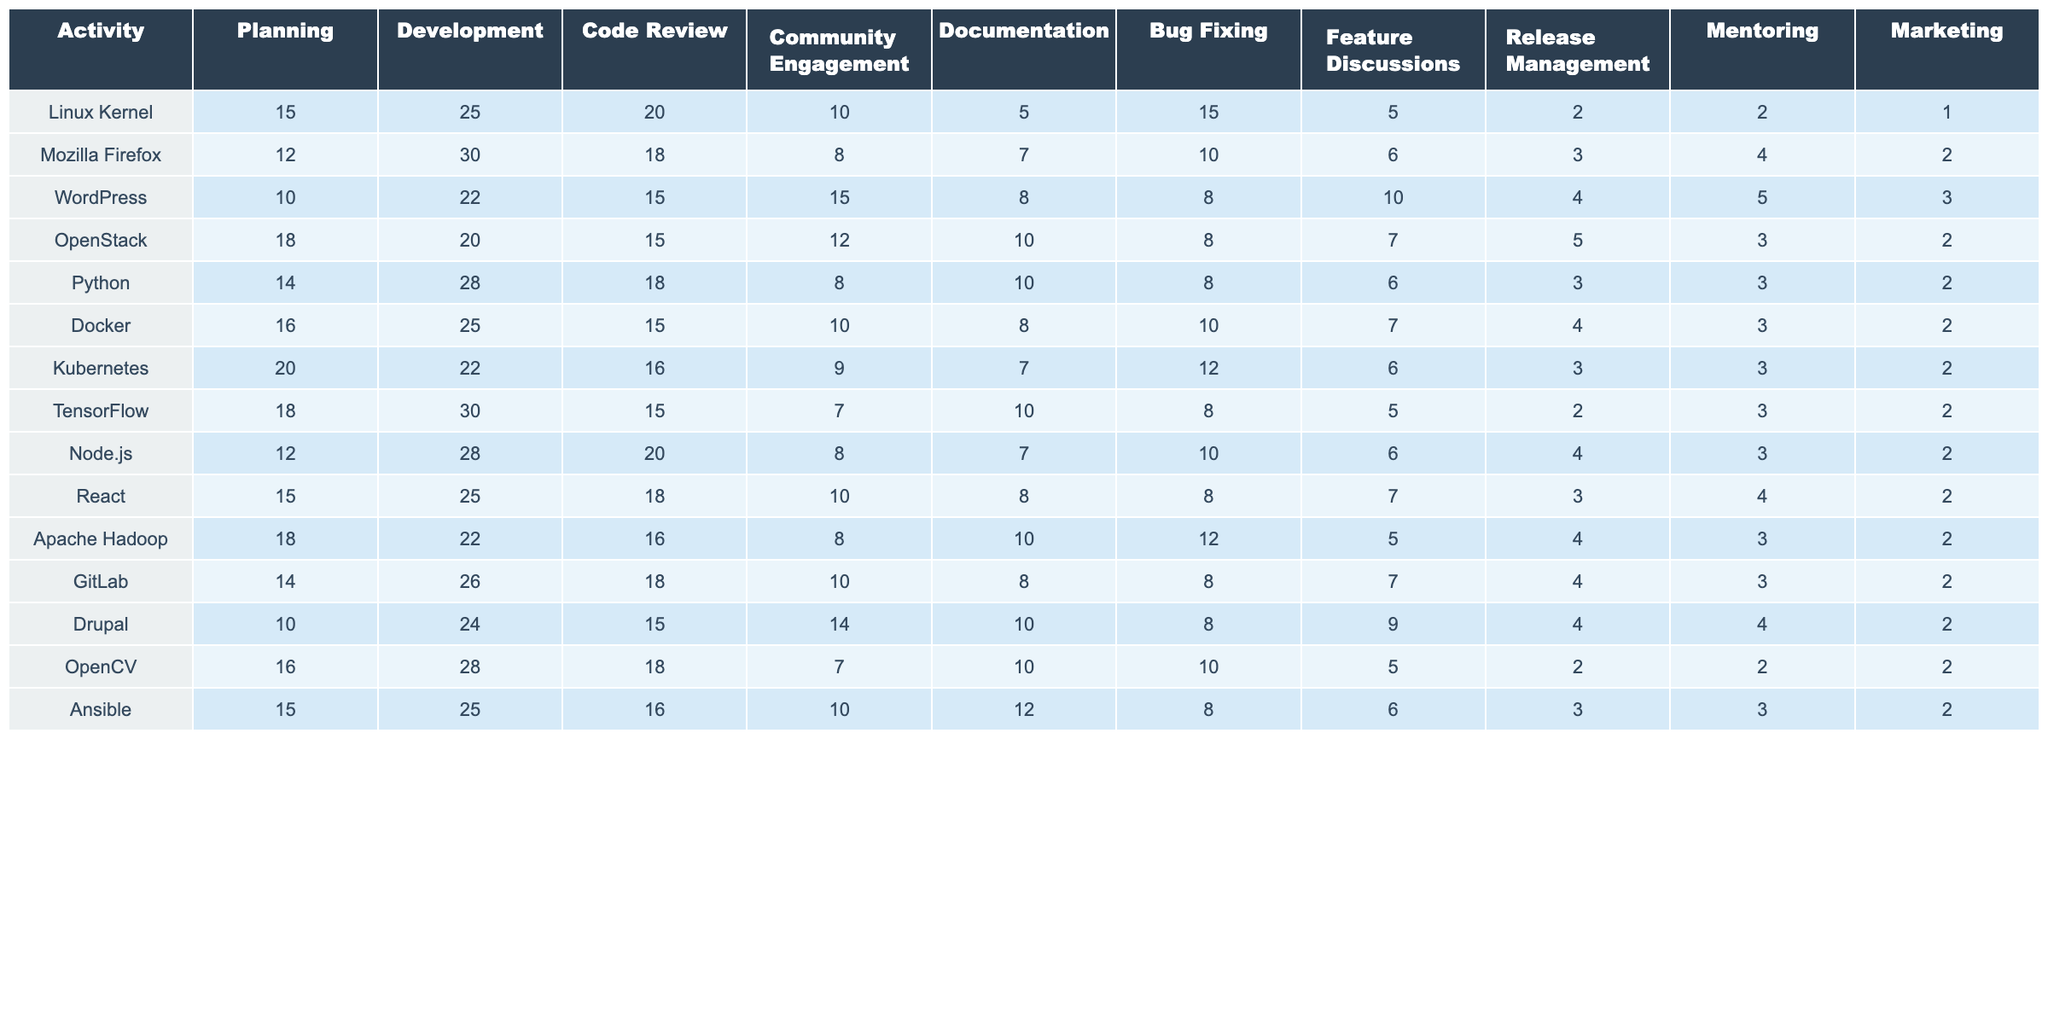What is the time allocated for Community Engagement in WordPress? Referring to the WordPress row in the table, the value for Community Engagement is 15.
Answer: 15 Which activity received the highest time allocation in the Linux Kernel project? Looking at the Linux Kernel row, the highest value is 25 for Development.
Answer: Development What is the average time allocated for Code Review across all projects? Adding all the Code Review values (20 + 18 + 15 + 15 + 18 + 15 + 16 + 15 + 20 + 18 + 16 + 18 + 15 + 18) = 221. There are 14 projects, so the average is 221/14 ≈ 15.79.
Answer: Approximately 15.79 Is the time allocated for Marketing in the Kubernetes project greater than in the OpenStack project? Comparing the Marketing values, Kubernetes has 2 while OpenStack has 2 as well. Since they are equal, the answer is no.
Answer: No Which project spends the most time on Mentoring? Looking through the Mentoring column, the highest value is 4 for multiple projects: Mozilla Firefox, Node.js, and GitLab. However, the maximum is the same in these projects.
Answer: Multiple projects (Mozilla Firefox, Node.js, GitLab) tie for max What is the total time allocated for Development across all projects? Summing the Development values (25 + 30 + 22 + 20 + 28 + 25 + 22 + 30 + 28 + 25 + 22 + 26 + 24 + 28) = 367.
Answer: 367 Which project has the least time allocated for Documentation? In the Documentation column, the least value is 5 from the Linux Kernel and Kubernetes projects.
Answer: Linux Kernel and Kubernetes What is the difference in time allocated to Bug Fixing between Python and Node.js? Python has 8 and Node.js has 10 allocated for Bug Fixing. The difference is 10 - 8 = 2.
Answer: 2 What is the total time allocated for feature discussions in all projects combined? All Feature Discussions values sum up to (5 + 6 + 10 + 7 + 6 + 7 + 6 + 5 + 6 + 7 + 5 + 9 + 5 + 6) = 73.
Answer: 73 Which project has a higher allocation for Planning: Docker or TensorFlow? Docker has 16 and TensorFlow has 18 for the Planning activity. Since 18 > 16, TensorFlow has a higher allocation.
Answer: TensorFlow What percentage of the total time allocated for activities in the WordPress project is spent on Documentation? In WordPress, the total time is (10 + 22 + 15 + 15 + 8 + 8 + 10 + 4 + 5 + 3) = 100. The time spent on Documentation is 8; thus, the percentage is (8/100)*100 = 8%.
Answer: 8% 